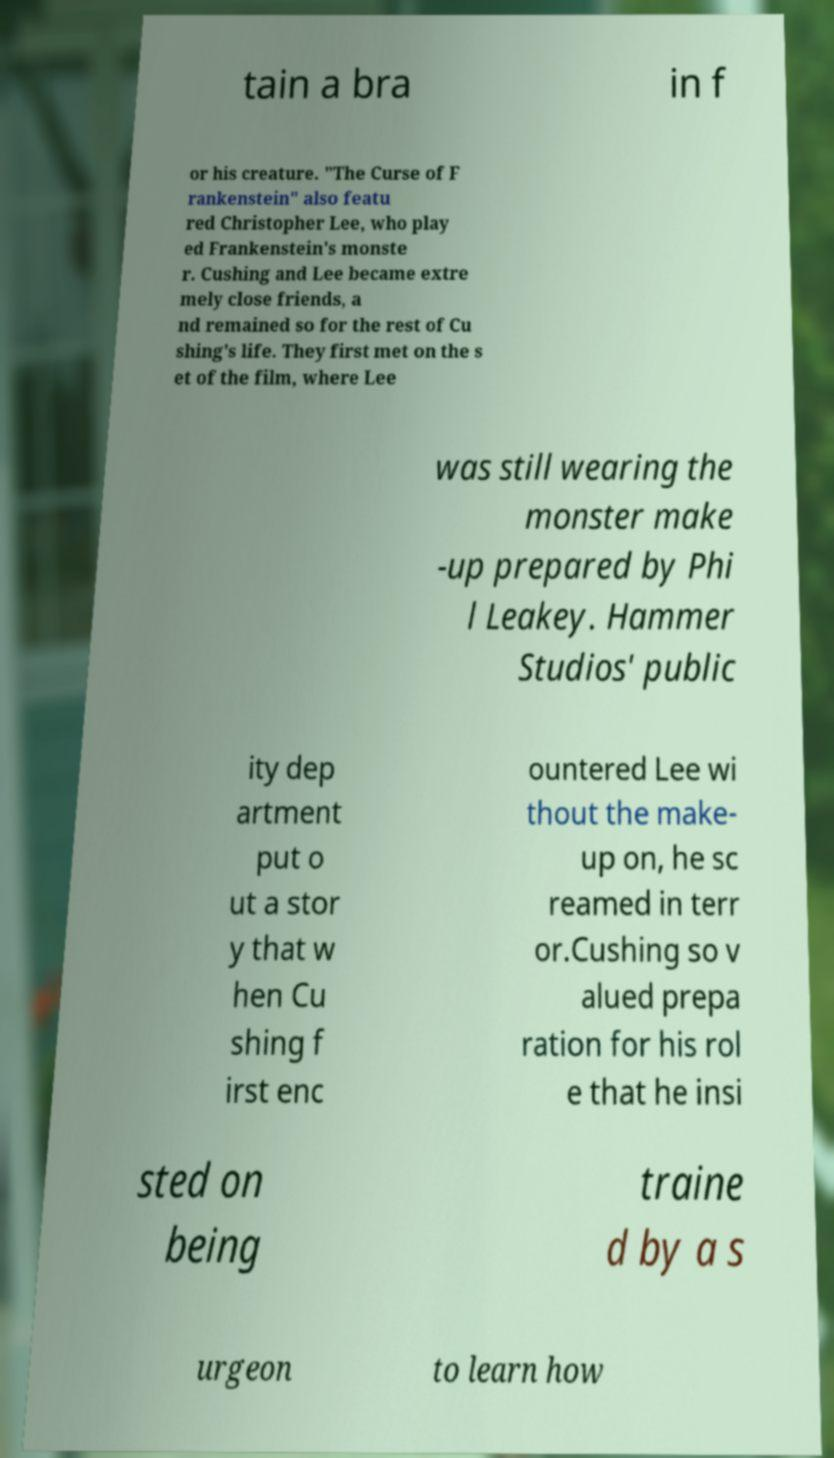Please identify and transcribe the text found in this image. tain a bra in f or his creature. "The Curse of F rankenstein" also featu red Christopher Lee, who play ed Frankenstein's monste r. Cushing and Lee became extre mely close friends, a nd remained so for the rest of Cu shing's life. They first met on the s et of the film, where Lee was still wearing the monster make -up prepared by Phi l Leakey. Hammer Studios' public ity dep artment put o ut a stor y that w hen Cu shing f irst enc ountered Lee wi thout the make- up on, he sc reamed in terr or.Cushing so v alued prepa ration for his rol e that he insi sted on being traine d by a s urgeon to learn how 